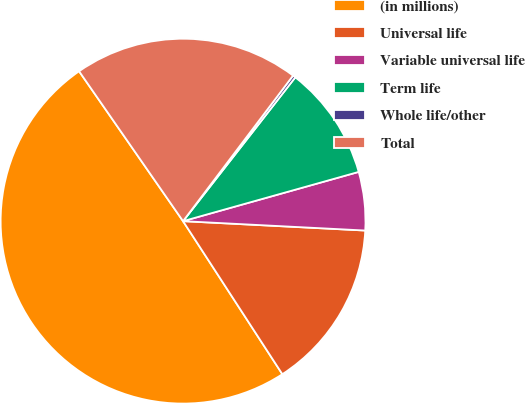Convert chart to OTSL. <chart><loc_0><loc_0><loc_500><loc_500><pie_chart><fcel>(in millions)<fcel>Universal life<fcel>Variable universal life<fcel>Term life<fcel>Whole life/other<fcel>Total<nl><fcel>49.51%<fcel>15.02%<fcel>5.17%<fcel>10.1%<fcel>0.25%<fcel>19.95%<nl></chart> 